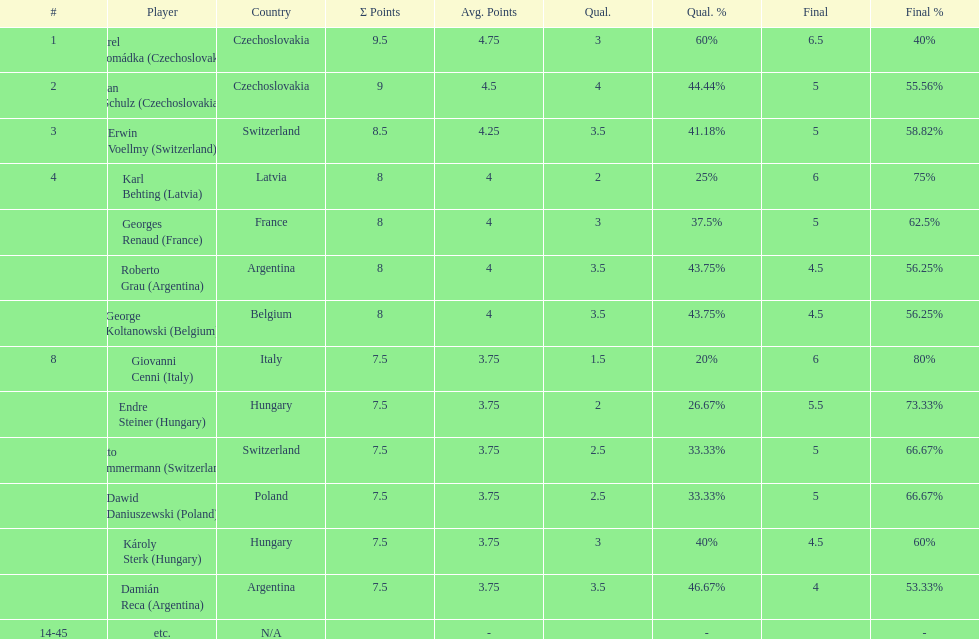How many players had a 8 points? 4. 